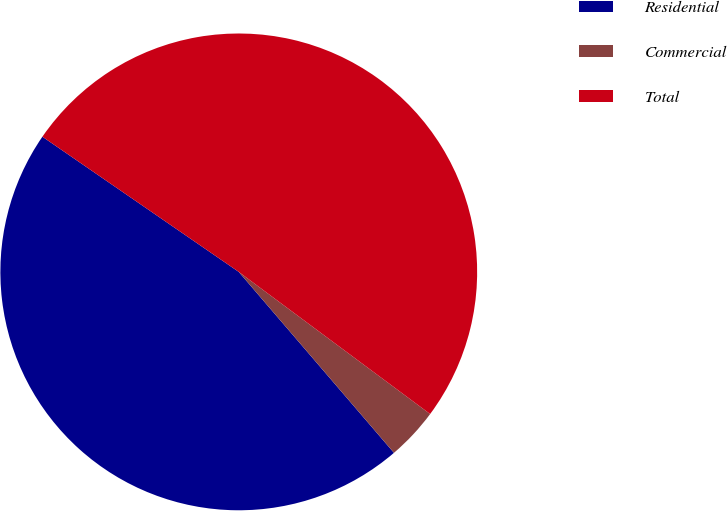<chart> <loc_0><loc_0><loc_500><loc_500><pie_chart><fcel>Residential<fcel>Commercial<fcel>Total<nl><fcel>45.88%<fcel>3.55%<fcel>50.57%<nl></chart> 